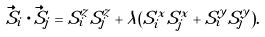Convert formula to latex. <formula><loc_0><loc_0><loc_500><loc_500>\vec { S } _ { i } \cdot \vec { S } _ { j } = S _ { i } ^ { z } S _ { j } ^ { z } + \lambda ( S _ { i } ^ { x } S _ { j } ^ { x } + S _ { i } ^ { y } S _ { j } ^ { y } ) .</formula> 